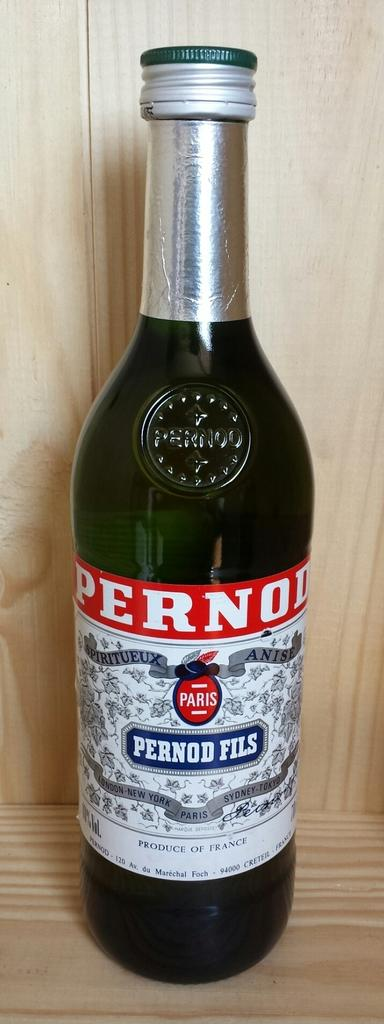<image>
Relay a brief, clear account of the picture shown. Bottle of pernod fils wine that is new and unopen 